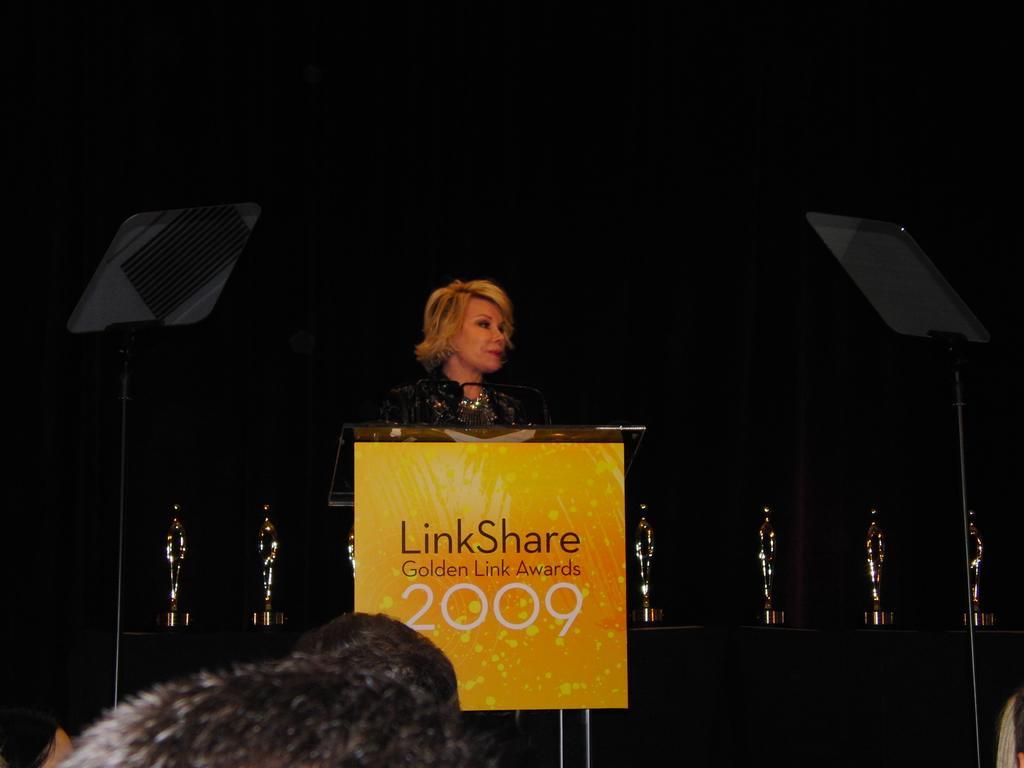In one or two sentences, can you explain what this image depicts? In this image a woman is standing behind the podium having a mike. Bottom of image there are few persons. Behind the women there are few shields on the table. 